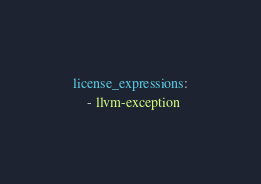<code> <loc_0><loc_0><loc_500><loc_500><_YAML_>license_expressions:
    - llvm-exception
</code> 